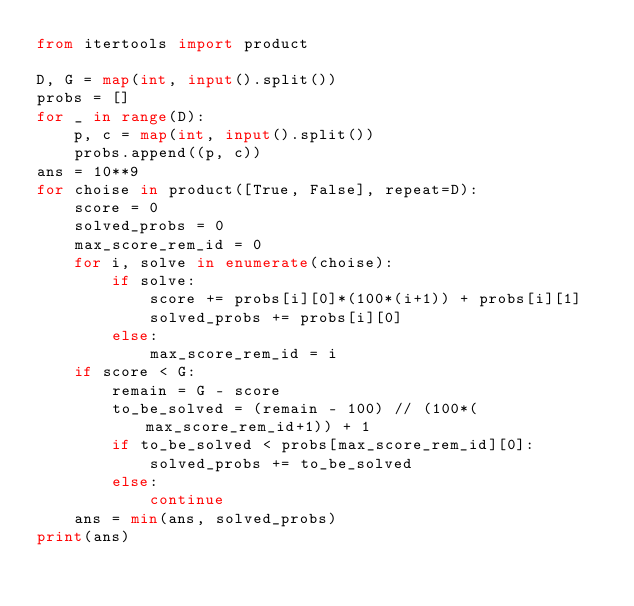<code> <loc_0><loc_0><loc_500><loc_500><_Python_>from itertools import product

D, G = map(int, input().split())
probs = []
for _ in range(D):
    p, c = map(int, input().split())
    probs.append((p, c))
ans = 10**9
for choise in product([True, False], repeat=D):
    score = 0
    solved_probs = 0
    max_score_rem_id = 0
    for i, solve in enumerate(choise):
        if solve:
            score += probs[i][0]*(100*(i+1)) + probs[i][1]
            solved_probs += probs[i][0]
        else:
            max_score_rem_id = i
    if score < G:
        remain = G - score
        to_be_solved = (remain - 100) // (100*(max_score_rem_id+1)) + 1
        if to_be_solved < probs[max_score_rem_id][0]:
            solved_probs += to_be_solved
        else:
            continue
    ans = min(ans, solved_probs)
print(ans)</code> 